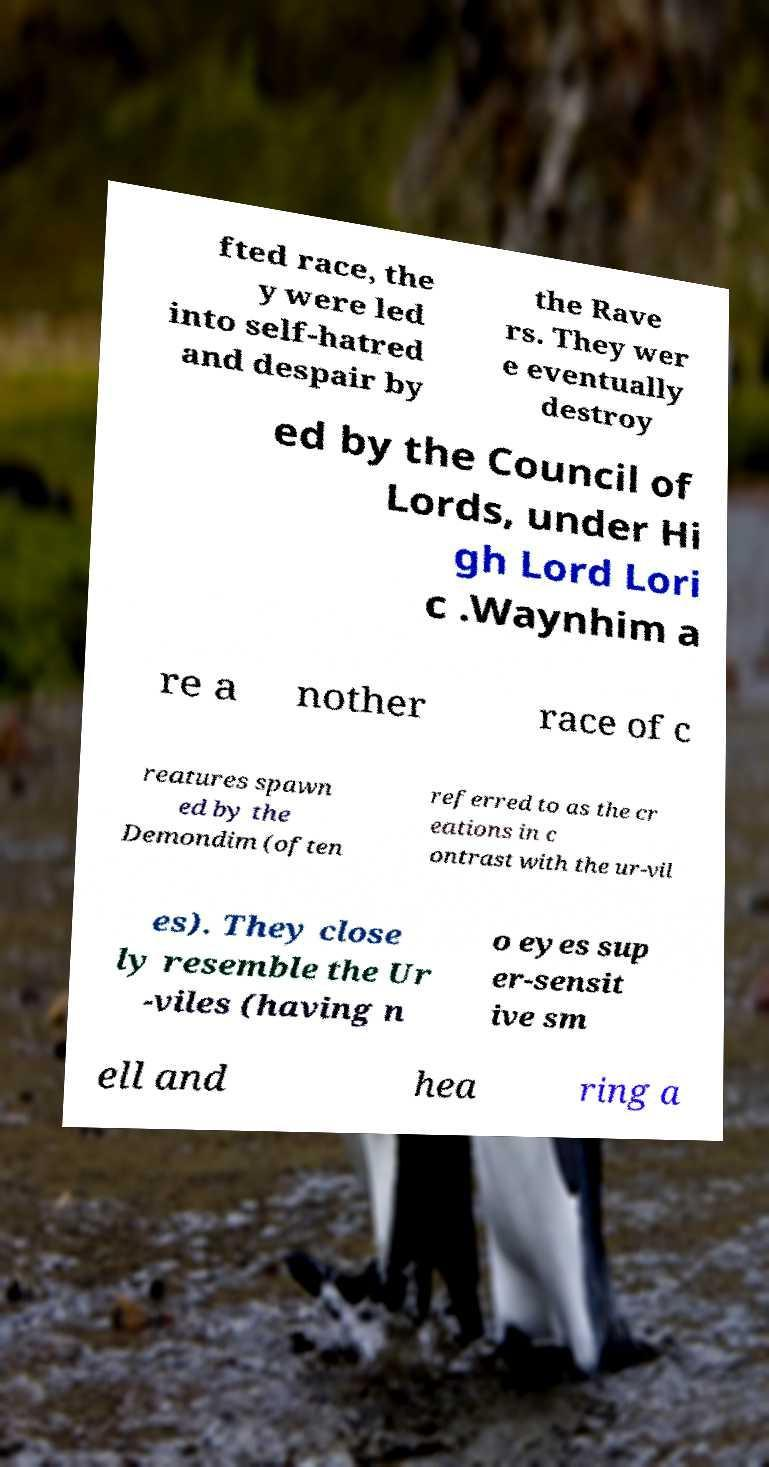What messages or text are displayed in this image? I need them in a readable, typed format. fted race, the y were led into self-hatred and despair by the Rave rs. They wer e eventually destroy ed by the Council of Lords, under Hi gh Lord Lori c .Waynhim a re a nother race of c reatures spawn ed by the Demondim (often referred to as the cr eations in c ontrast with the ur-vil es). They close ly resemble the Ur -viles (having n o eyes sup er-sensit ive sm ell and hea ring a 